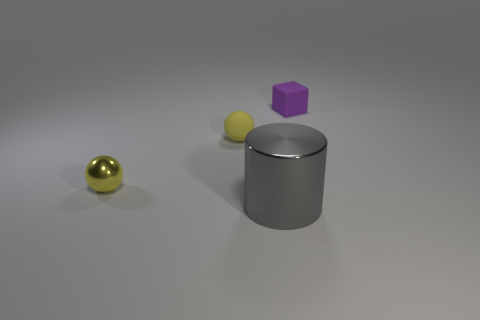Are there any other things that are the same size as the gray cylinder?
Keep it short and to the point. No. What is the size of the matte cube?
Offer a very short reply. Small. Is the number of balls behind the yellow metallic thing the same as the number of yellow rubber spheres?
Offer a very short reply. Yes. What number of other objects are the same color as the rubber ball?
Provide a succinct answer. 1. There is a small thing that is both to the right of the tiny metal sphere and on the left side of the big gray cylinder; what color is it?
Offer a terse response. Yellow. What size is the rubber thing that is on the left side of the small thing right of the rubber object that is to the left of the small purple matte thing?
Give a very brief answer. Small. What number of objects are objects in front of the tiny purple matte cube or matte objects that are right of the gray cylinder?
Ensure brevity in your answer.  4. What shape is the tiny yellow metallic object?
Keep it short and to the point. Sphere. What number of other objects are the same material as the large gray object?
Your answer should be very brief. 1. There is another thing that is the same shape as the yellow matte object; what is its size?
Provide a short and direct response. Small. 